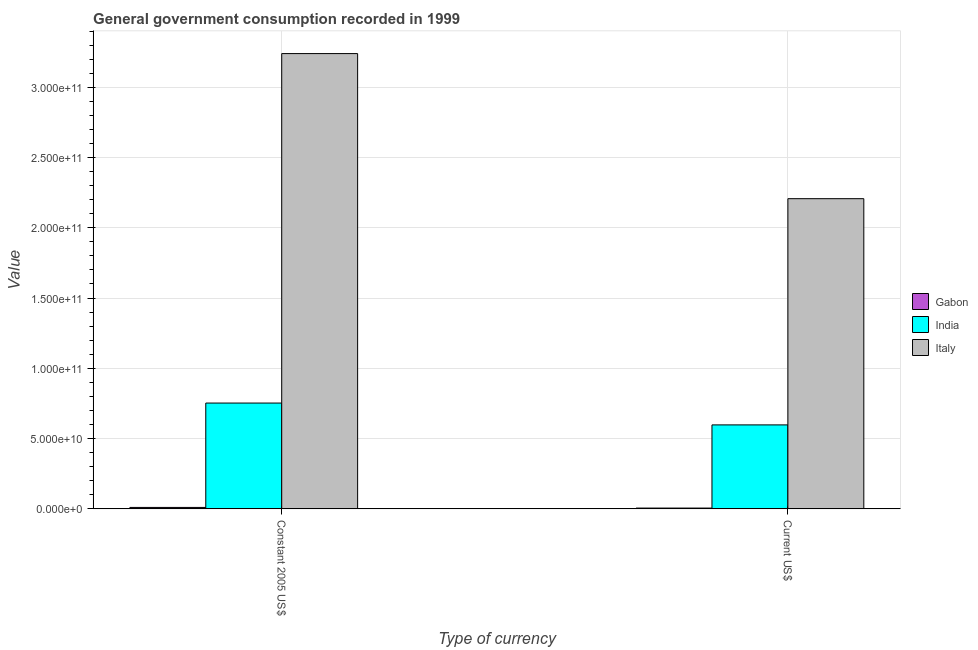How many groups of bars are there?
Keep it short and to the point. 2. How many bars are there on the 2nd tick from the right?
Offer a very short reply. 3. What is the label of the 2nd group of bars from the left?
Provide a short and direct response. Current US$. What is the value consumed in constant 2005 us$ in Italy?
Offer a terse response. 3.24e+11. Across all countries, what is the maximum value consumed in constant 2005 us$?
Your answer should be compact. 3.24e+11. Across all countries, what is the minimum value consumed in current us$?
Ensure brevity in your answer.  5.49e+08. In which country was the value consumed in current us$ minimum?
Make the answer very short. Gabon. What is the total value consumed in current us$ in the graph?
Your response must be concise. 2.81e+11. What is the difference between the value consumed in constant 2005 us$ in India and that in Italy?
Make the answer very short. -2.49e+11. What is the difference between the value consumed in current us$ in Italy and the value consumed in constant 2005 us$ in Gabon?
Make the answer very short. 2.20e+11. What is the average value consumed in current us$ per country?
Offer a terse response. 9.37e+1. What is the difference between the value consumed in current us$ and value consumed in constant 2005 us$ in Gabon?
Your answer should be very brief. -4.61e+08. What is the ratio of the value consumed in current us$ in Italy to that in India?
Give a very brief answer. 3.69. What does the 3rd bar from the right in Constant 2005 US$ represents?
Provide a short and direct response. Gabon. How many bars are there?
Give a very brief answer. 6. Are all the bars in the graph horizontal?
Ensure brevity in your answer.  No. Does the graph contain any zero values?
Offer a terse response. No. Does the graph contain grids?
Your answer should be compact. Yes. How many legend labels are there?
Your answer should be compact. 3. How are the legend labels stacked?
Offer a terse response. Vertical. What is the title of the graph?
Offer a terse response. General government consumption recorded in 1999. Does "St. Lucia" appear as one of the legend labels in the graph?
Offer a terse response. No. What is the label or title of the X-axis?
Your answer should be very brief. Type of currency. What is the label or title of the Y-axis?
Offer a terse response. Value. What is the Value of Gabon in Constant 2005 US$?
Your response must be concise. 1.01e+09. What is the Value in India in Constant 2005 US$?
Keep it short and to the point. 7.53e+1. What is the Value in Italy in Constant 2005 US$?
Your answer should be very brief. 3.24e+11. What is the Value of Gabon in Current US$?
Offer a terse response. 5.49e+08. What is the Value of India in Current US$?
Provide a short and direct response. 5.97e+1. What is the Value of Italy in Current US$?
Keep it short and to the point. 2.21e+11. Across all Type of currency, what is the maximum Value of Gabon?
Ensure brevity in your answer.  1.01e+09. Across all Type of currency, what is the maximum Value of India?
Keep it short and to the point. 7.53e+1. Across all Type of currency, what is the maximum Value of Italy?
Keep it short and to the point. 3.24e+11. Across all Type of currency, what is the minimum Value of Gabon?
Offer a very short reply. 5.49e+08. Across all Type of currency, what is the minimum Value in India?
Offer a terse response. 5.97e+1. Across all Type of currency, what is the minimum Value of Italy?
Offer a very short reply. 2.21e+11. What is the total Value in Gabon in the graph?
Offer a terse response. 1.56e+09. What is the total Value of India in the graph?
Keep it short and to the point. 1.35e+11. What is the total Value in Italy in the graph?
Ensure brevity in your answer.  5.45e+11. What is the difference between the Value in Gabon in Constant 2005 US$ and that in Current US$?
Provide a short and direct response. 4.61e+08. What is the difference between the Value in India in Constant 2005 US$ and that in Current US$?
Provide a short and direct response. 1.55e+1. What is the difference between the Value in Italy in Constant 2005 US$ and that in Current US$?
Offer a terse response. 1.03e+11. What is the difference between the Value of Gabon in Constant 2005 US$ and the Value of India in Current US$?
Offer a very short reply. -5.87e+1. What is the difference between the Value of Gabon in Constant 2005 US$ and the Value of Italy in Current US$?
Make the answer very short. -2.20e+11. What is the difference between the Value in India in Constant 2005 US$ and the Value in Italy in Current US$?
Make the answer very short. -1.45e+11. What is the average Value of Gabon per Type of currency?
Your answer should be very brief. 7.80e+08. What is the average Value of India per Type of currency?
Your response must be concise. 6.75e+1. What is the average Value of Italy per Type of currency?
Your answer should be compact. 2.72e+11. What is the difference between the Value of Gabon and Value of India in Constant 2005 US$?
Make the answer very short. -7.43e+1. What is the difference between the Value in Gabon and Value in Italy in Constant 2005 US$?
Your answer should be compact. -3.23e+11. What is the difference between the Value of India and Value of Italy in Constant 2005 US$?
Your answer should be compact. -2.49e+11. What is the difference between the Value of Gabon and Value of India in Current US$?
Offer a very short reply. -5.92e+1. What is the difference between the Value in Gabon and Value in Italy in Current US$?
Your answer should be very brief. -2.20e+11. What is the difference between the Value of India and Value of Italy in Current US$?
Keep it short and to the point. -1.61e+11. What is the ratio of the Value in Gabon in Constant 2005 US$ to that in Current US$?
Provide a succinct answer. 1.84. What is the ratio of the Value in India in Constant 2005 US$ to that in Current US$?
Make the answer very short. 1.26. What is the ratio of the Value in Italy in Constant 2005 US$ to that in Current US$?
Offer a terse response. 1.47. What is the difference between the highest and the second highest Value in Gabon?
Keep it short and to the point. 4.61e+08. What is the difference between the highest and the second highest Value of India?
Your answer should be very brief. 1.55e+1. What is the difference between the highest and the second highest Value of Italy?
Make the answer very short. 1.03e+11. What is the difference between the highest and the lowest Value in Gabon?
Your answer should be compact. 4.61e+08. What is the difference between the highest and the lowest Value of India?
Offer a terse response. 1.55e+1. What is the difference between the highest and the lowest Value of Italy?
Provide a succinct answer. 1.03e+11. 